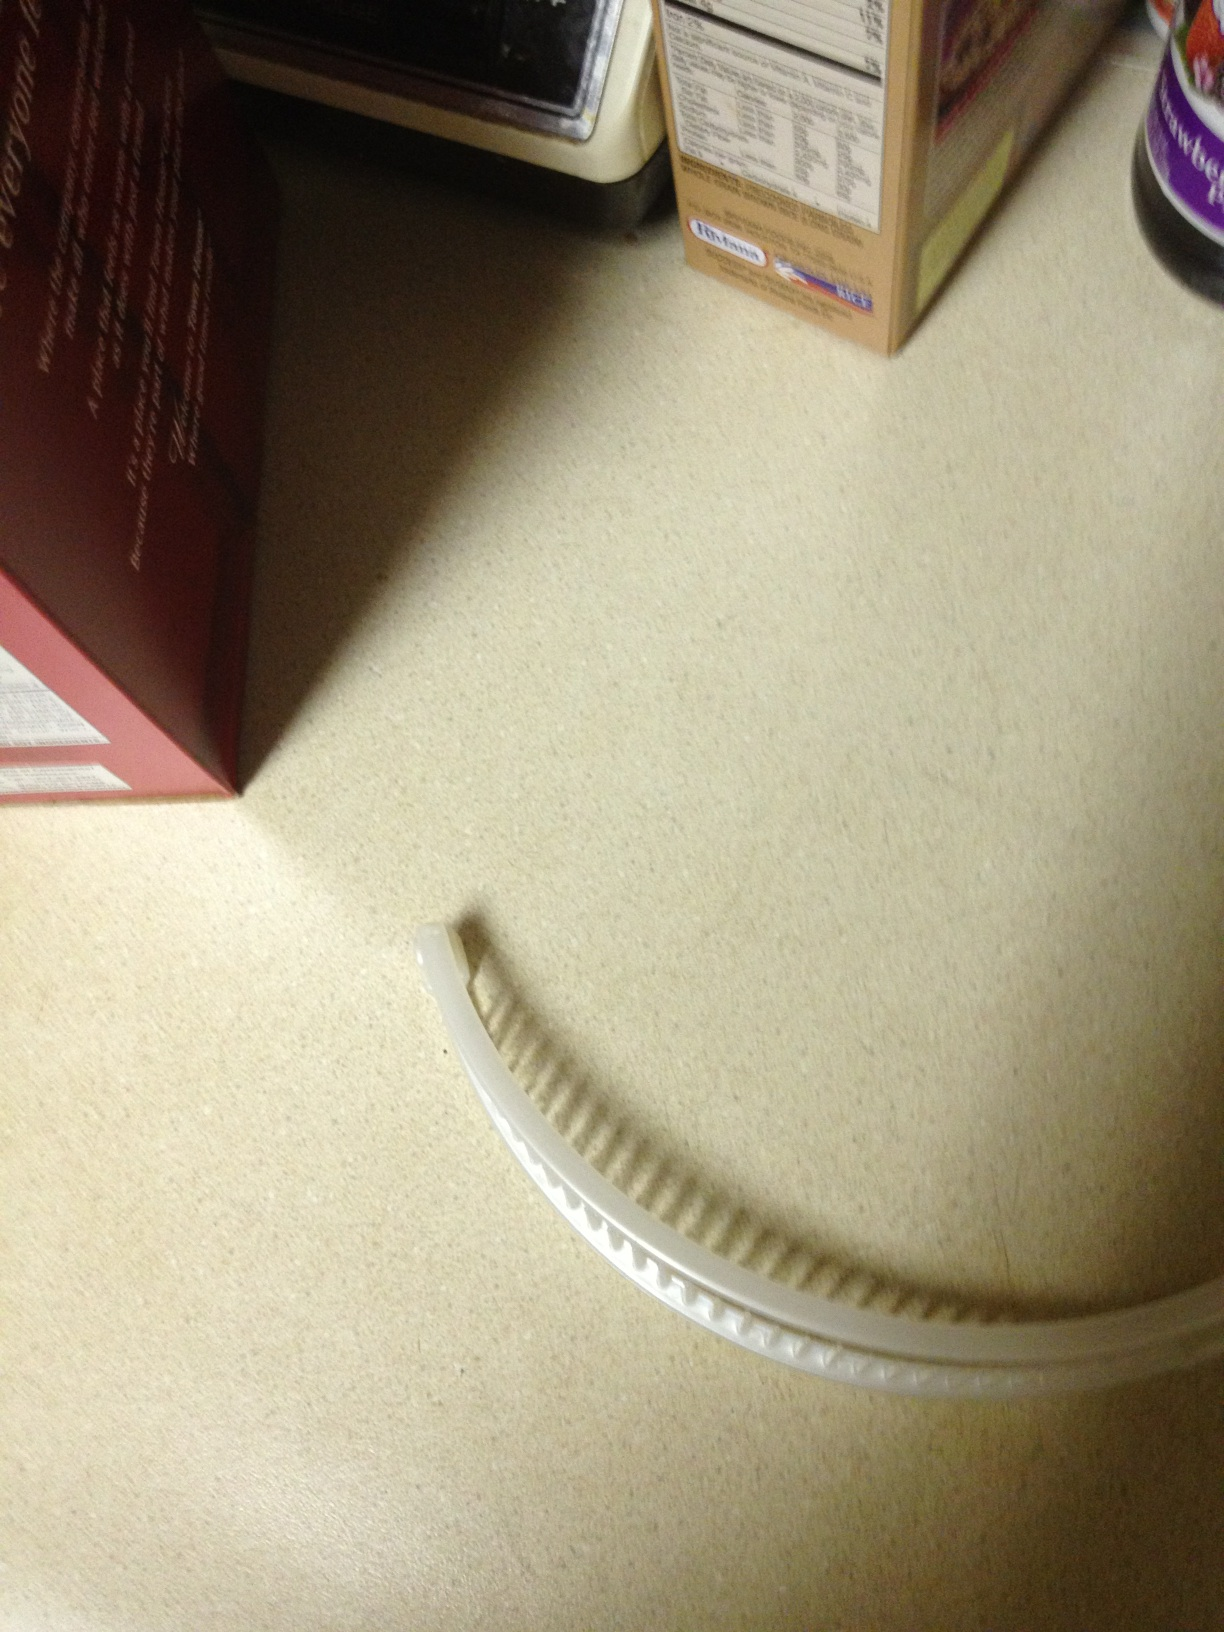What material does the banana hair clip appear to be made of in the image? The banana hair clip looks to be made of plastic, characterized by its smooth and glossy finish. 